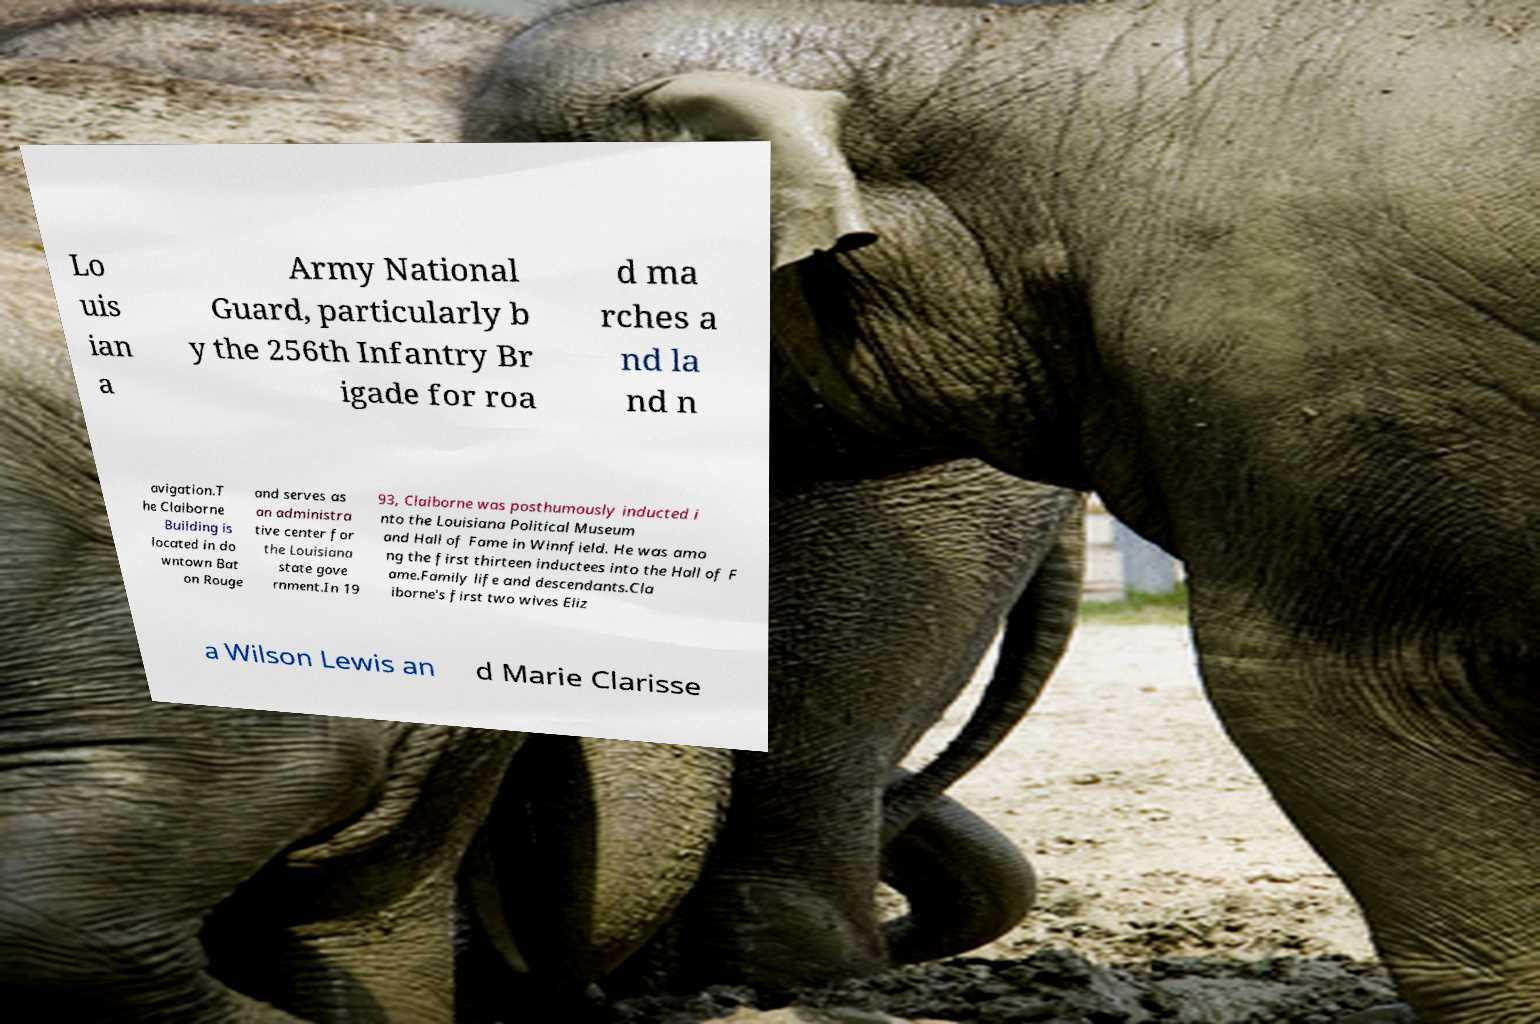Could you extract and type out the text from this image? Lo uis ian a Army National Guard, particularly b y the 256th Infantry Br igade for roa d ma rches a nd la nd n avigation.T he Claiborne Building is located in do wntown Bat on Rouge and serves as an administra tive center for the Louisiana state gove rnment.In 19 93, Claiborne was posthumously inducted i nto the Louisiana Political Museum and Hall of Fame in Winnfield. He was amo ng the first thirteen inductees into the Hall of F ame.Family life and descendants.Cla iborne's first two wives Eliz a Wilson Lewis an d Marie Clarisse 